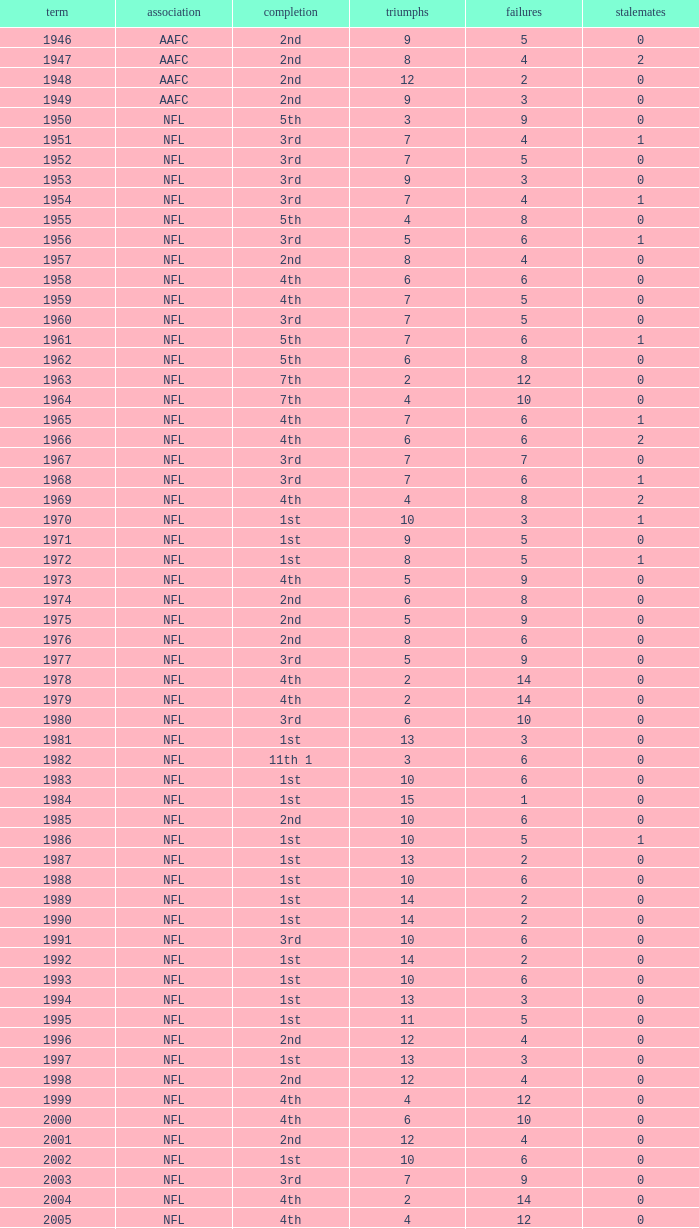What is the maximum number of wins for an nfl team finishing 1st with over 6 losses? None. 